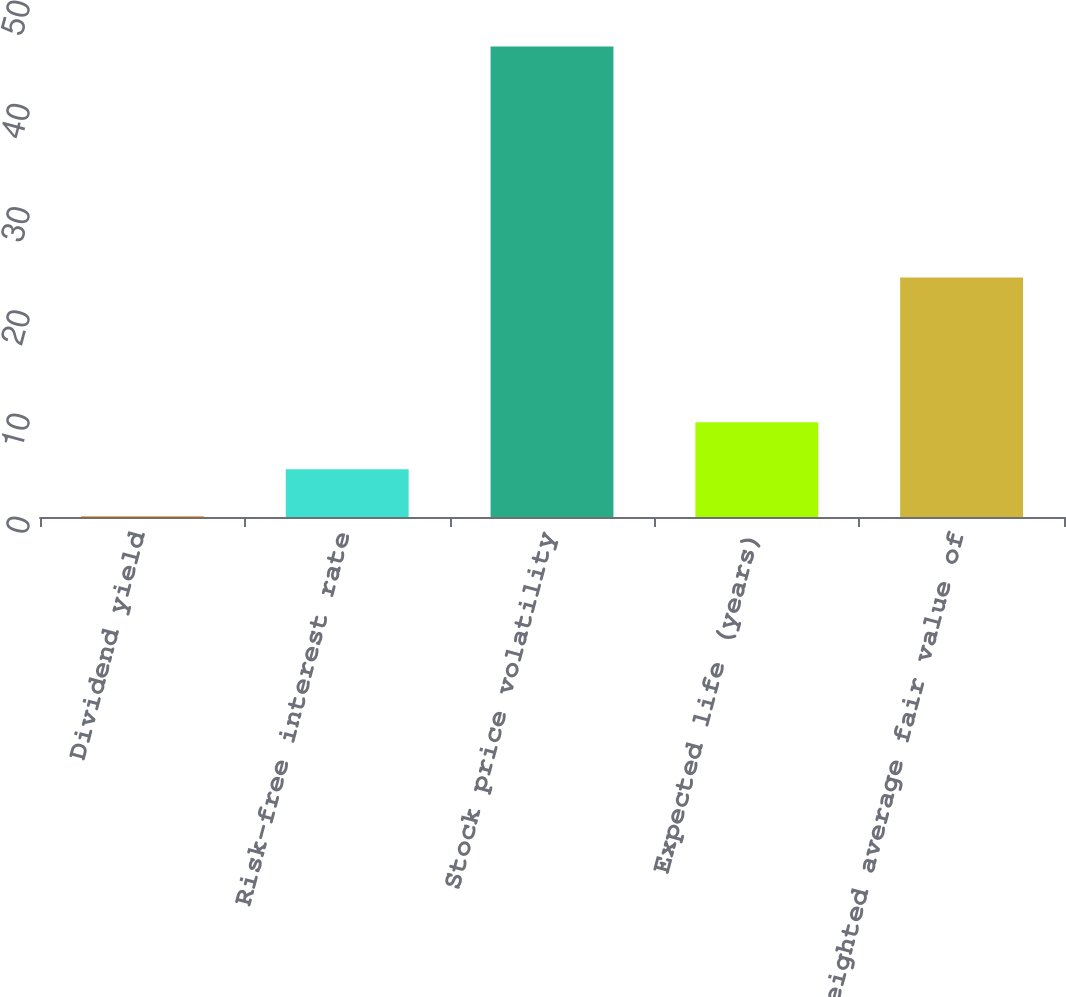<chart> <loc_0><loc_0><loc_500><loc_500><bar_chart><fcel>Dividend yield<fcel>Risk-free interest rate<fcel>Stock price volatility<fcel>Expected life (years)<fcel>Weighted average fair value of<nl><fcel>0.08<fcel>4.63<fcel>45.6<fcel>9.18<fcel>23.2<nl></chart> 